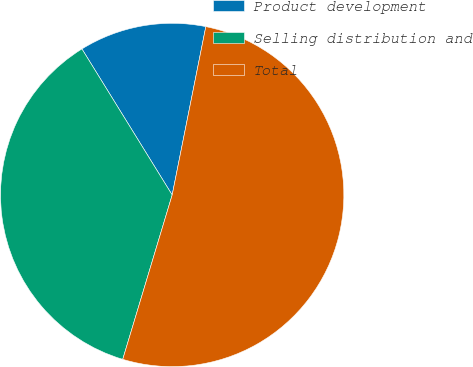Convert chart. <chart><loc_0><loc_0><loc_500><loc_500><pie_chart><fcel>Product development<fcel>Selling distribution and<fcel>Total<nl><fcel>11.95%<fcel>36.54%<fcel>51.51%<nl></chart> 